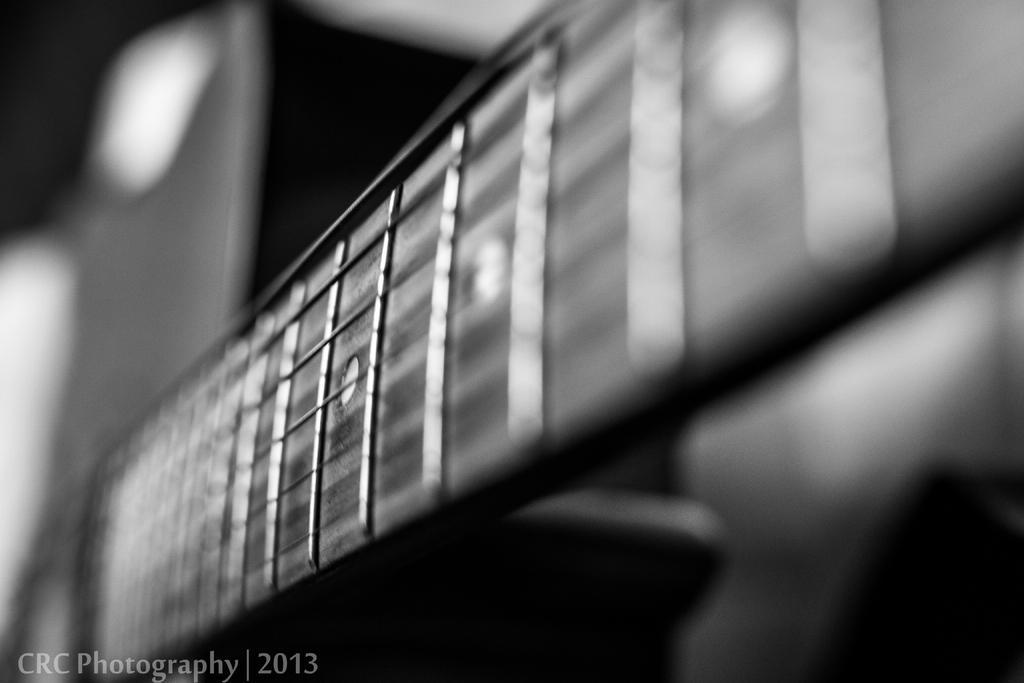Can you describe this image briefly? This image is consists of monochrome. 